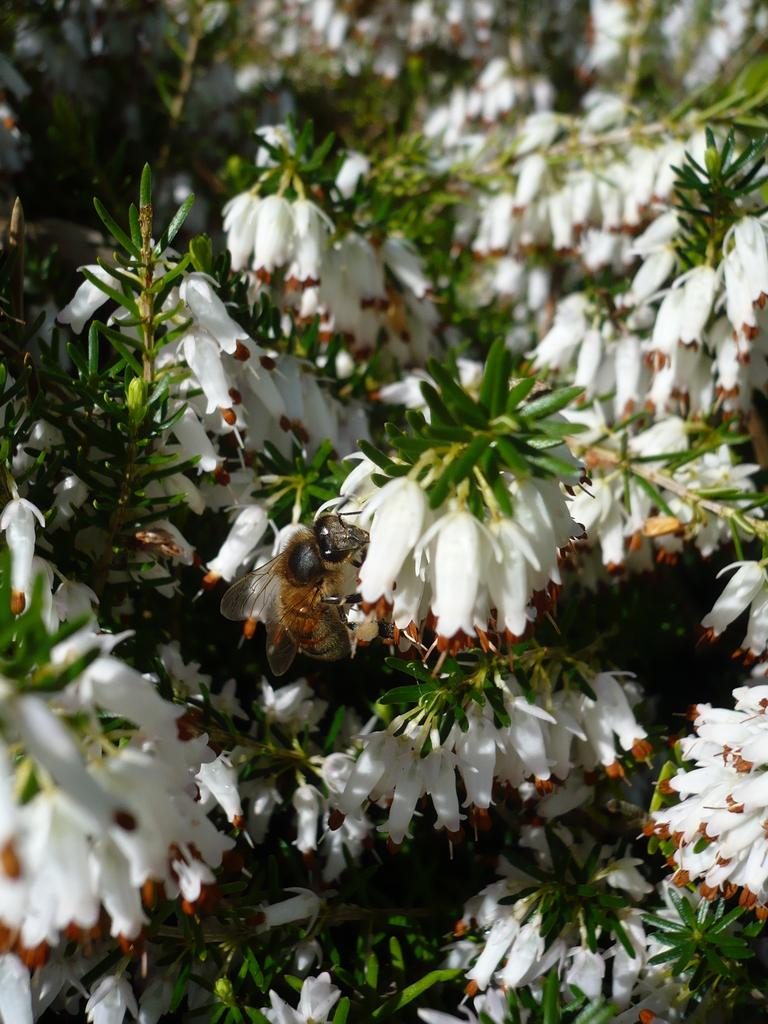What type of plants can be seen in the image? There are flowers in the image. Are there any animals present in the image? Yes, there is a honey bee on the flowers. How many cars are parked near the flowers in the image? There are no cars present in the image; it only features flowers and a honey bee. What letters can be seen on the baby's shirt in the image? There is no baby or shirt present in the image; it only features flowers and a honey bee. 